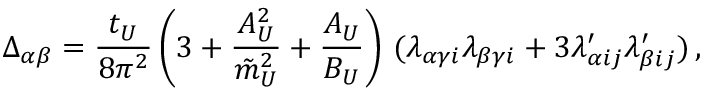<formula> <loc_0><loc_0><loc_500><loc_500>\Delta _ { \alpha \beta } = { \frac { t _ { U } } { 8 \pi ^ { 2 } } } \left ( 3 + { \frac { A _ { U } ^ { 2 } } { \tilde { m } _ { U } ^ { 2 } } } + { \frac { A _ { U } } { B _ { U } } } \right ) \, ( \lambda _ { \alpha \gamma i } \lambda _ { \beta \gamma i } + 3 \lambda _ { \alpha i j } ^ { \prime } \lambda _ { \beta i j } ^ { \prime } ) \, ,</formula> 